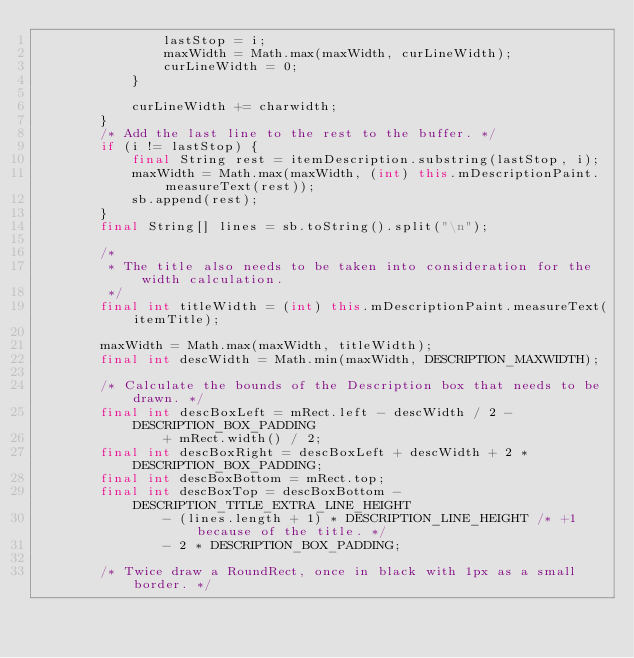Convert code to text. <code><loc_0><loc_0><loc_500><loc_500><_Java_>				lastStop = i;
				maxWidth = Math.max(maxWidth, curLineWidth);
				curLineWidth = 0;
			}

			curLineWidth += charwidth;
		}
		/* Add the last line to the rest to the buffer. */
		if (i != lastStop) {
			final String rest = itemDescription.substring(lastStop, i);
			maxWidth = Math.max(maxWidth, (int) this.mDescriptionPaint.measureText(rest));
			sb.append(rest);
		}
		final String[] lines = sb.toString().split("\n");

		/*
		 * The title also needs to be taken into consideration for the width calculation.
		 */
		final int titleWidth = (int) this.mDescriptionPaint.measureText(itemTitle);

		maxWidth = Math.max(maxWidth, titleWidth);
		final int descWidth = Math.min(maxWidth, DESCRIPTION_MAXWIDTH);

		/* Calculate the bounds of the Description box that needs to be drawn. */
		final int descBoxLeft = mRect.left - descWidth / 2 - DESCRIPTION_BOX_PADDING
				+ mRect.width() / 2;
		final int descBoxRight = descBoxLeft + descWidth + 2 * DESCRIPTION_BOX_PADDING;
		final int descBoxBottom = mRect.top;
		final int descBoxTop = descBoxBottom - DESCRIPTION_TITLE_EXTRA_LINE_HEIGHT
				- (lines.length + 1) * DESCRIPTION_LINE_HEIGHT /* +1 because of the title. */
				- 2 * DESCRIPTION_BOX_PADDING;

		/* Twice draw a RoundRect, once in black with 1px as a small border. */</code> 